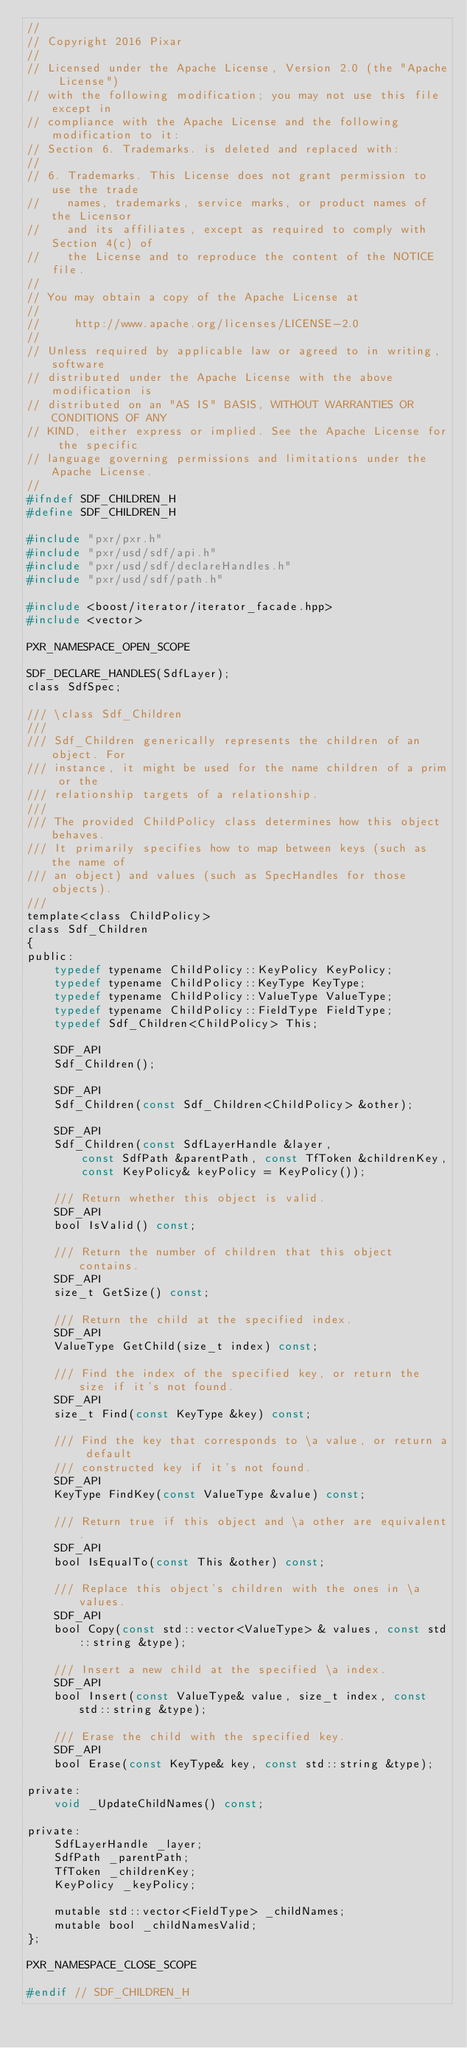Convert code to text. <code><loc_0><loc_0><loc_500><loc_500><_C_>//
// Copyright 2016 Pixar
//
// Licensed under the Apache License, Version 2.0 (the "Apache License")
// with the following modification; you may not use this file except in
// compliance with the Apache License and the following modification to it:
// Section 6. Trademarks. is deleted and replaced with:
//
// 6. Trademarks. This License does not grant permission to use the trade
//    names, trademarks, service marks, or product names of the Licensor
//    and its affiliates, except as required to comply with Section 4(c) of
//    the License and to reproduce the content of the NOTICE file.
//
// You may obtain a copy of the Apache License at
//
//     http://www.apache.org/licenses/LICENSE-2.0
//
// Unless required by applicable law or agreed to in writing, software
// distributed under the Apache License with the above modification is
// distributed on an "AS IS" BASIS, WITHOUT WARRANTIES OR CONDITIONS OF ANY
// KIND, either express or implied. See the Apache License for the specific
// language governing permissions and limitations under the Apache License.
//
#ifndef SDF_CHILDREN_H
#define SDF_CHILDREN_H

#include "pxr/pxr.h"
#include "pxr/usd/sdf/api.h"
#include "pxr/usd/sdf/declareHandles.h"
#include "pxr/usd/sdf/path.h"

#include <boost/iterator/iterator_facade.hpp>
#include <vector>

PXR_NAMESPACE_OPEN_SCOPE

SDF_DECLARE_HANDLES(SdfLayer);
class SdfSpec;

/// \class Sdf_Children
///
/// Sdf_Children generically represents the children of an object. For
/// instance, it might be used for the name children of a prim or the
/// relationship targets of a relationship.
///
/// The provided ChildPolicy class determines how this object behaves.
/// It primarily specifies how to map between keys (such as the name of
/// an object) and values (such as SpecHandles for those objects).
///
template<class ChildPolicy>
class Sdf_Children
{
public:
    typedef typename ChildPolicy::KeyPolicy KeyPolicy;
    typedef typename ChildPolicy::KeyType KeyType;
    typedef typename ChildPolicy::ValueType ValueType;
    typedef typename ChildPolicy::FieldType FieldType;
    typedef Sdf_Children<ChildPolicy> This;

    SDF_API
    Sdf_Children();

    SDF_API
    Sdf_Children(const Sdf_Children<ChildPolicy> &other);

    SDF_API
    Sdf_Children(const SdfLayerHandle &layer,
        const SdfPath &parentPath, const TfToken &childrenKey,
        const KeyPolicy& keyPolicy = KeyPolicy());

    /// Return whether this object is valid.
    SDF_API
    bool IsValid() const;

    /// Return the number of children that this object contains.
    SDF_API
    size_t GetSize() const;

    /// Return the child at the specified index.
    SDF_API
    ValueType GetChild(size_t index) const;

    /// Find the index of the specified key, or return the size if it's not found.
    SDF_API
    size_t Find(const KeyType &key) const;
    
    /// Find the key that corresponds to \a value, or return a default
    /// constructed key if it's not found.
    SDF_API
    KeyType FindKey(const ValueType &value) const;

    /// Return true if this object and \a other are equivalent.
    SDF_API
    bool IsEqualTo(const This &other) const;

    /// Replace this object's children with the ones in \a values.
    SDF_API
    bool Copy(const std::vector<ValueType> & values, const std::string &type);
    
    /// Insert a new child at the specified \a index.
    SDF_API
    bool Insert(const ValueType& value, size_t index, const std::string &type);

    /// Erase the child with the specified key.
    SDF_API
    bool Erase(const KeyType& key, const std::string &type);

private:
    void _UpdateChildNames() const;
    
private:
    SdfLayerHandle _layer;
    SdfPath _parentPath;
    TfToken _childrenKey;
    KeyPolicy _keyPolicy;
    
    mutable std::vector<FieldType> _childNames;
    mutable bool _childNamesValid;
};

PXR_NAMESPACE_CLOSE_SCOPE

#endif // SDF_CHILDREN_H
</code> 